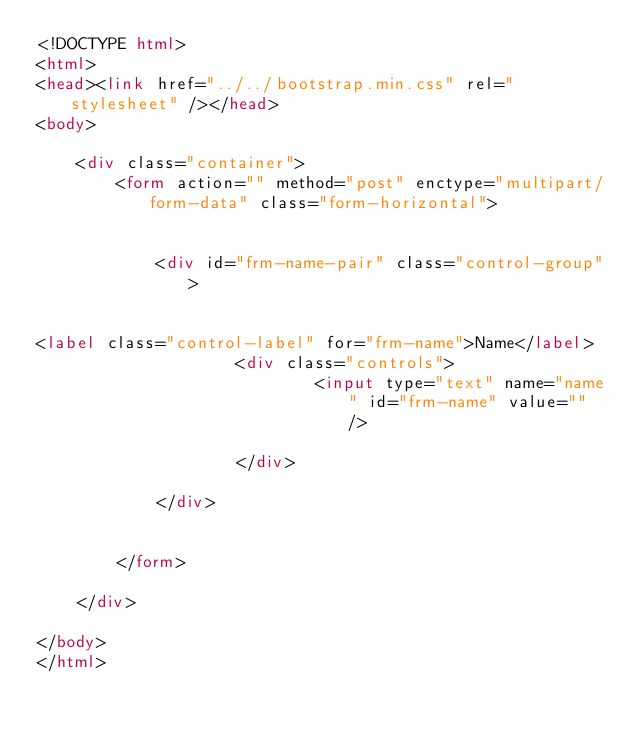Convert code to text. <code><loc_0><loc_0><loc_500><loc_500><_HTML_><!DOCTYPE html>
<html>
<head><link href="../../bootstrap.min.css" rel="stylesheet" /></head>
<body>

    <div class="container">
        <form action="" method="post" enctype="multipart/form-data" class="form-horizontal">


            <div id="frm-name-pair" class="control-group">


<label class="control-label" for="frm-name">Name</label>
                    <div class="controls">
                            <input type="text" name="name" id="frm-name" value="" />

                    </div>

            </div>


        </form>

	</div>

</body>
</html>
</code> 